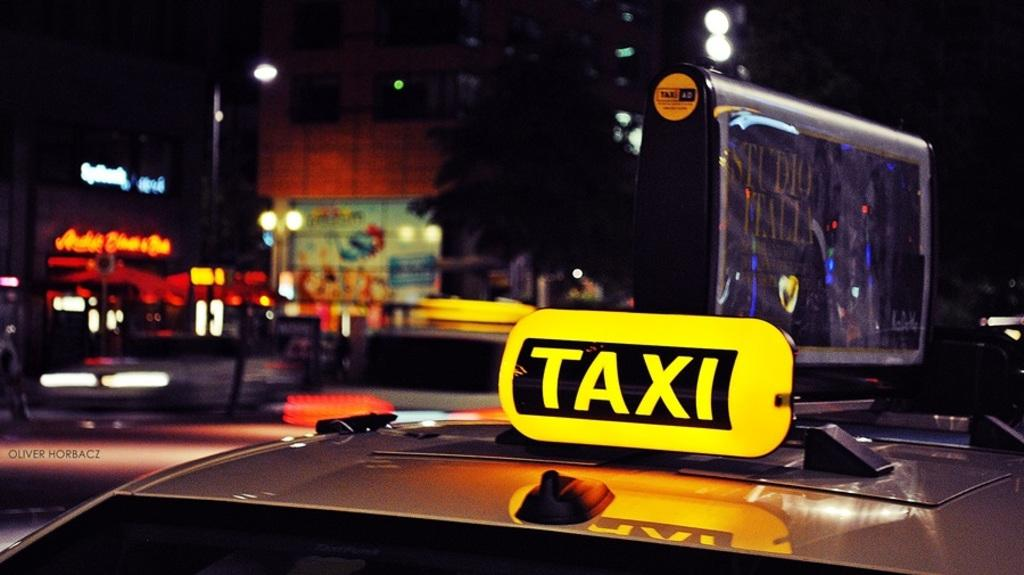<image>
Create a compact narrative representing the image presented. a cab with the word taxi on top of it 